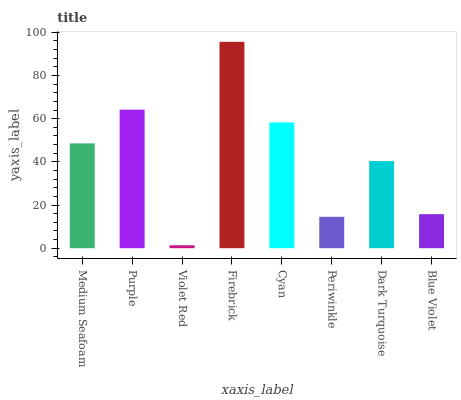Is Violet Red the minimum?
Answer yes or no. Yes. Is Firebrick the maximum?
Answer yes or no. Yes. Is Purple the minimum?
Answer yes or no. No. Is Purple the maximum?
Answer yes or no. No. Is Purple greater than Medium Seafoam?
Answer yes or no. Yes. Is Medium Seafoam less than Purple?
Answer yes or no. Yes. Is Medium Seafoam greater than Purple?
Answer yes or no. No. Is Purple less than Medium Seafoam?
Answer yes or no. No. Is Medium Seafoam the high median?
Answer yes or no. Yes. Is Dark Turquoise the low median?
Answer yes or no. Yes. Is Violet Red the high median?
Answer yes or no. No. Is Purple the low median?
Answer yes or no. No. 